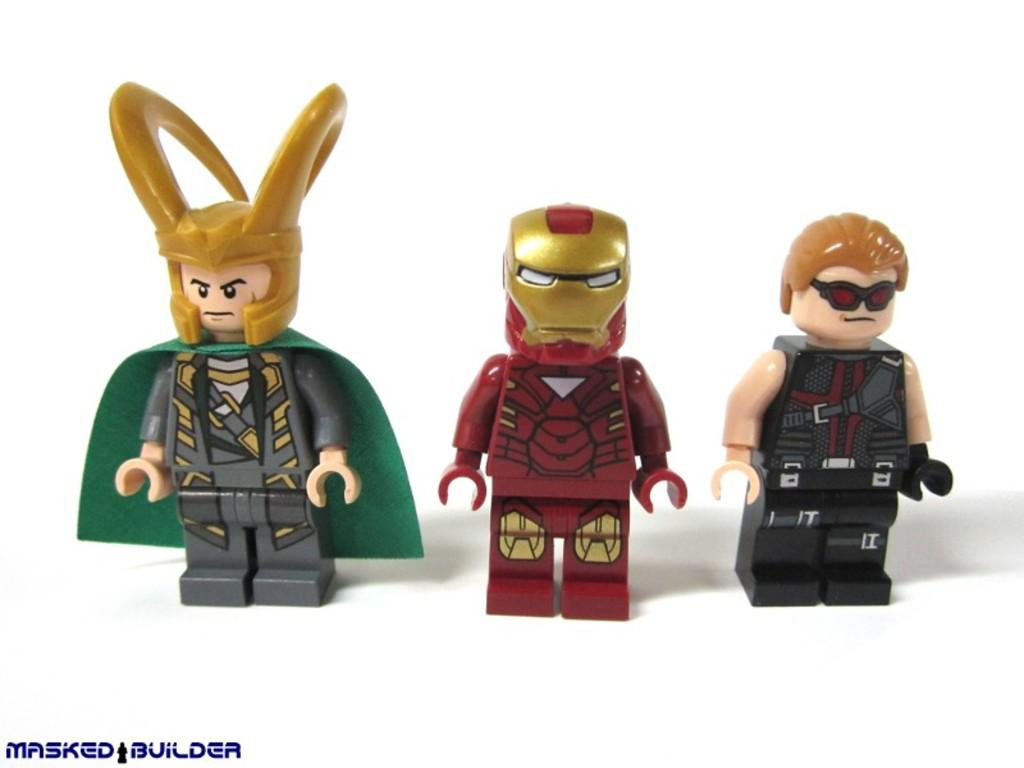How many toys are present in the image? There are three toys in the image. What colors can be seen on the toys? The toys have various colors, including grey, green, maroon, gold, black, and cream. What is the surface on which the toys are placed? The toys are on a white-colored surface. What color is the background of the image? The background of the image is white. Is there a volcano erupting in the background of the image? No, there is no volcano or any indication of an eruption in the image. 